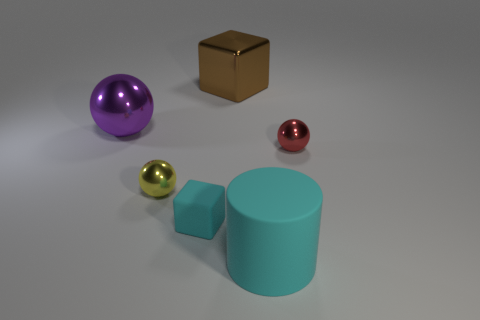Does the large shiny object that is behind the big purple object have the same color as the large object that is in front of the big purple shiny ball?
Your response must be concise. No. There is a tiny matte object; how many purple objects are to the left of it?
Give a very brief answer. 1. There is a tiny sphere right of the large matte cylinder to the left of the red thing; are there any objects that are behind it?
Ensure brevity in your answer.  Yes. What number of other yellow metallic objects have the same size as the yellow thing?
Offer a terse response. 0. What is the material of the big object that is right of the metallic thing behind the large purple metal sphere?
Your answer should be very brief. Rubber. There is a small metallic object that is left of the small metal object that is to the right of the tiny metal thing that is to the left of the large metal cube; what shape is it?
Offer a very short reply. Sphere. There is a large object that is in front of the small rubber object; does it have the same shape as the small object that is to the left of the small cyan matte cube?
Your response must be concise. No. How many other objects are the same material as the small cube?
Offer a terse response. 1. The object that is the same material as the large cylinder is what shape?
Keep it short and to the point. Cube. Is the size of the brown metal thing the same as the cyan cylinder?
Your response must be concise. Yes. 